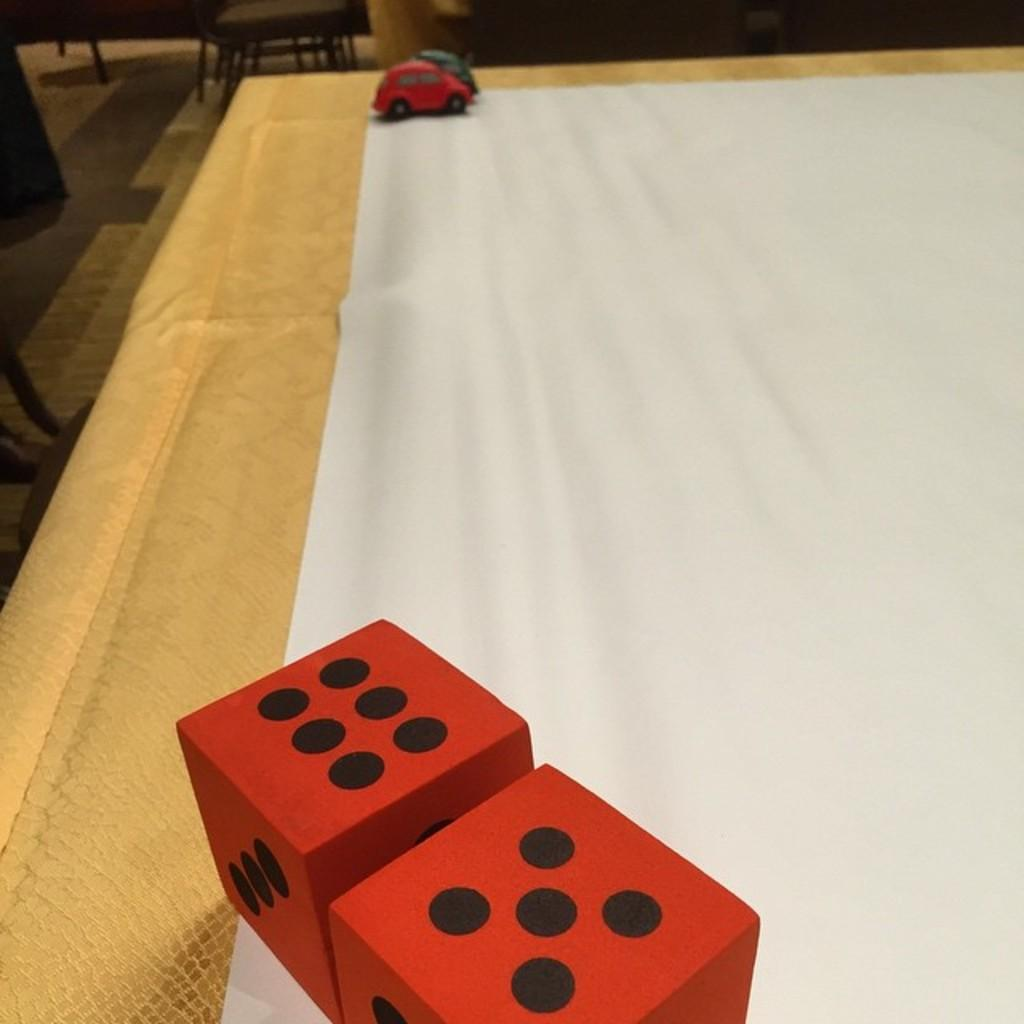What is the main object in the image? There is a white cloth in the image. What is placed on the white cloth? There are two cars and two dice on the surface of the white cloth. What type of beast can be seen interacting with the minister in the image? There is no beast or minister present in the image; it only features a white cloth with two cars and two dice. 